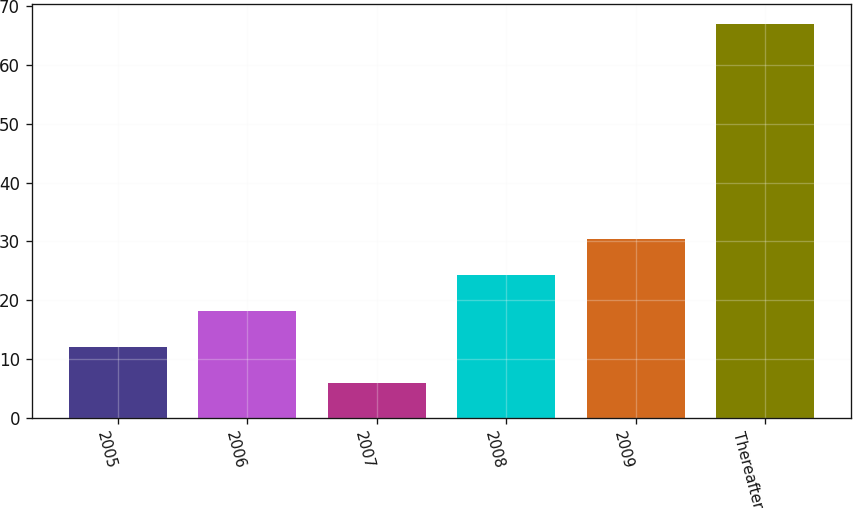Convert chart to OTSL. <chart><loc_0><loc_0><loc_500><loc_500><bar_chart><fcel>2005<fcel>2006<fcel>2007<fcel>2008<fcel>2009<fcel>Thereafter<nl><fcel>12.1<fcel>18.2<fcel>6<fcel>24.3<fcel>30.4<fcel>67<nl></chart> 